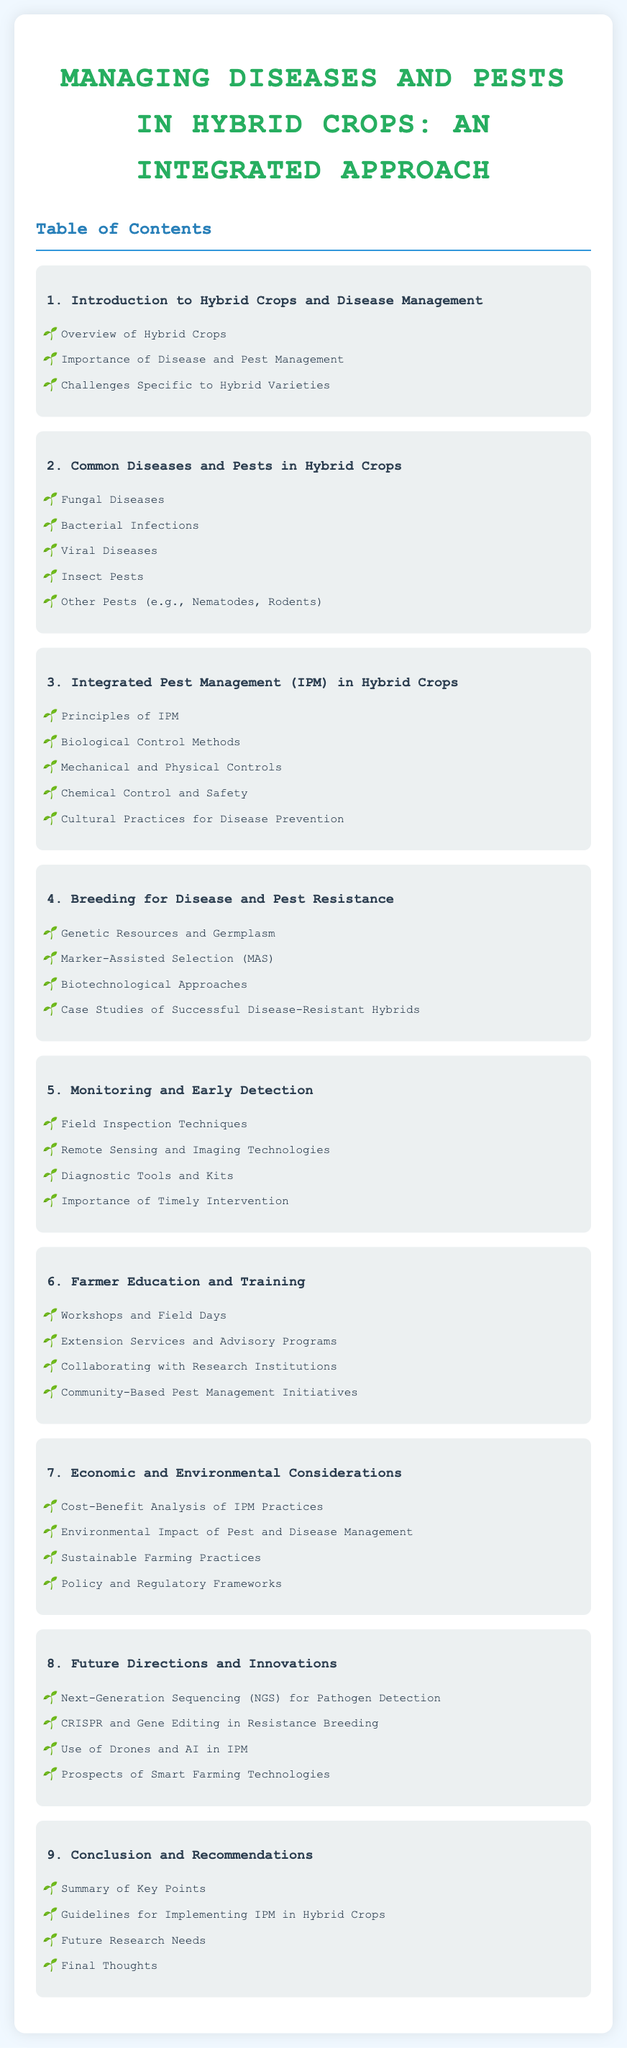What is the first section of the document? The first section of the document is titled "Introduction to Hybrid Crops and Disease Management."
Answer: Introduction to Hybrid Crops and Disease Management How many types of diseases and pests are listed? There are five types of diseases and pests listed in the second section.
Answer: 5 What is one method mentioned under Integrated Pest Management? One method mentioned under Integrated Pest Management is "Biological Control Methods."
Answer: Biological Control Methods What kind of analysis is covered in the economic considerations section? The economic considerations section covers "Cost-Benefit Analysis of IPM Practices."
Answer: Cost-Benefit Analysis of IPM Practices What innovative technology is mentioned in the future directions section? The future directions section mentions "CRISPR and Gene Editing in Resistance Breeding."
Answer: CRISPR and Gene Editing in Resistance Breeding 